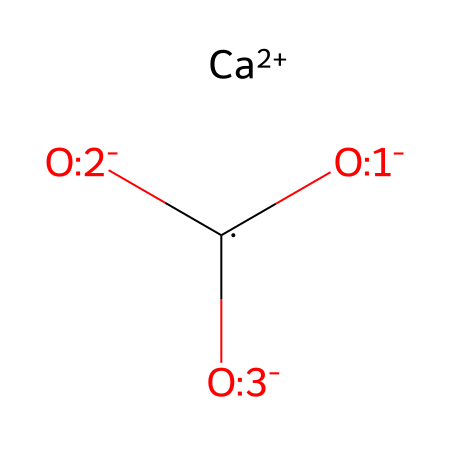What is the central atom in this structure? The central atom in the structure of calcium carbonate is carbon, as it is the atom bonded to the three oxygen atoms and the single calcium atom in this formula.
Answer: carbon How many oxygen atoms are present in this chemical structure? Upon examining the SMILES representation, there are three distinct oxygen atoms that are bonded to the central carbon atom, indicating that this structure contains three oxygen atoms.
Answer: three What charge does the calcium ion carry in this structure? The SMILES shows that calcium is written as [Ca+2], which specifies that the calcium ion has a charge of +2.
Answer: +2 What type of bond connects calcium to carbonate in this structure? In the definition of this structure, calcium ion (Ca²⁺) interacts ionically with the carbonate ion (CO₃²⁻), characterized by electrostatic attraction, indicating an ionic bond.
Answer: ionic bond How many total atoms are in the calcium carbonate formula? The total number combines the calcium atom, the carbon atom, and the three oxygen atoms: 1 (Ca) + 1 (C) + 3 (O) = 5 total atoms.
Answer: five What role does this compound (calcium carbonate) have in gardening? Calcium carbonate is known to adjust soil pH by acting as a liming agent, which neutralizes acidic soils, promoting healthier plant growth.
Answer: pH adjustment 